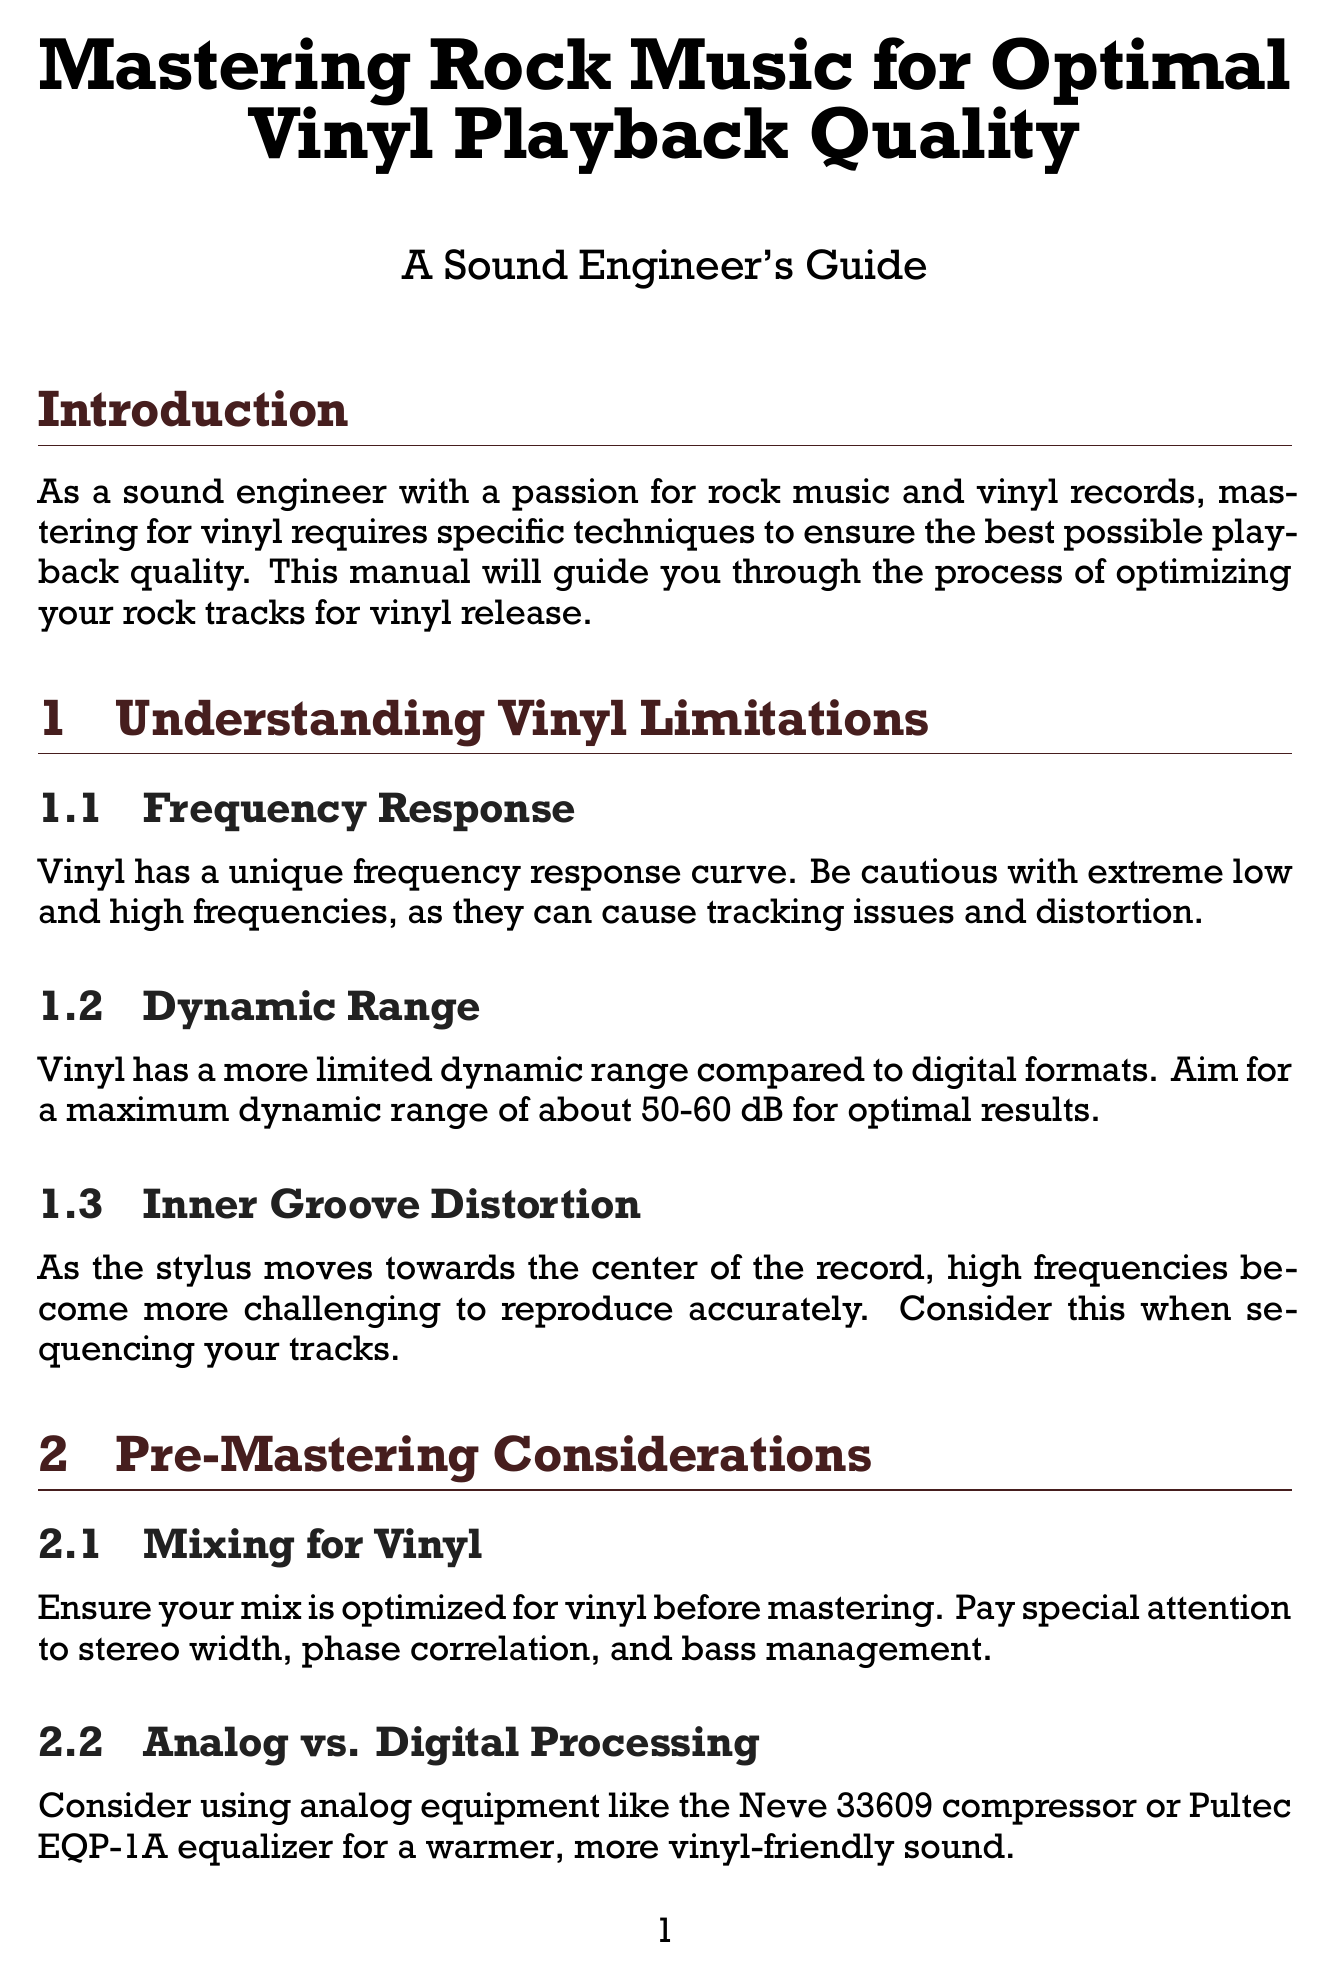What is the maximum dynamic range for vinyl? The manual states that vinyl has a more limited dynamic range, aiming for a maximum of about 50-60 dB for optimal results.
Answer: 50-60 dB What plugin can be used to check mono compatibility? The document mentions using a specific plugin to check the master in mono to ensure proper phase correlation.
Answer: Brainworx bx_solo What is the function of a high-pass filter in vinyl mastering? The manual suggests applying a gentle high-pass filter to remove sub-bass frequencies that can cause cutting and playback issues.
Answer: Remove sub-bass frequencies What is the integrated LUFS target for rock music on vinyl? The document provides a target range for integrated LUFS measurements specifically for rock music on vinyl.
Answer: -14 to -12 LUFS What should be considered when sequencing tracks for vinyl? The manual highlights a distortion issue that occurs as the stylus moves toward the center of the record that should be accounted for in track sequencing.
Answer: Inner Groove Distortion What type of compressor is recommended for achieving a warmer sound? The manual suggests the use of specific analog equipment known for providing a warm sound during the mastering process.
Answer: Neve 33609 compressor How often should test pressings be evaluated before approval? The document emphasizes the importance of evaluating test pressings before final product approval, implying consistency in this practice.
Answer: Always Which mastering software is mentioned in the document? The document lists mastering software that is suitable for the vinyl mastering process.
Answer: iZotope Ozone 9 Advanced 